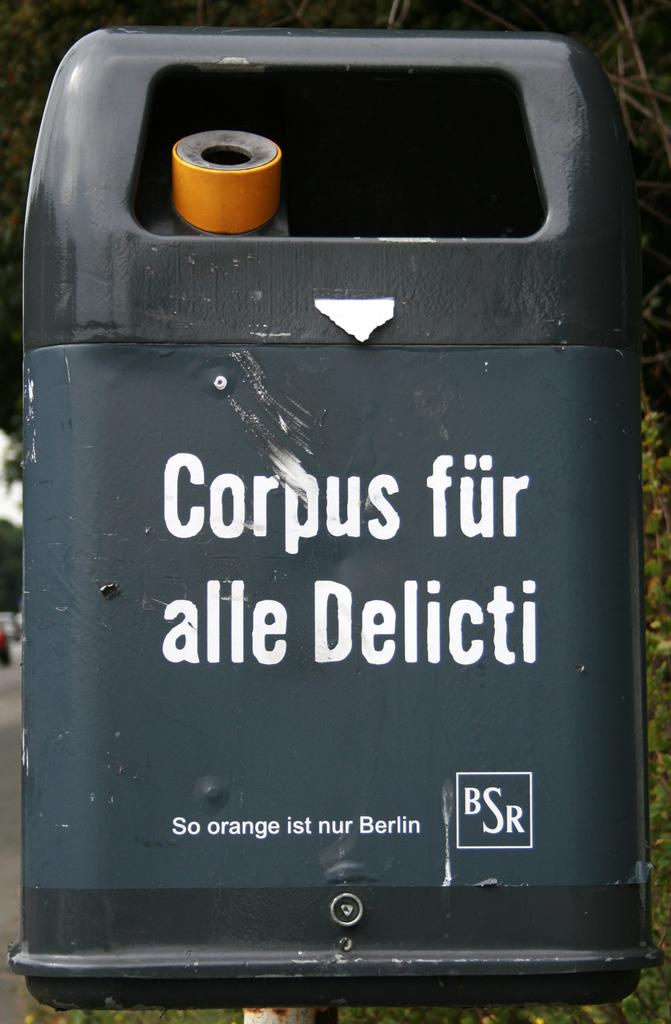<image>
Offer a succinct explanation of the picture presented. A back container has the words corpus fur alle delicti on the front. 